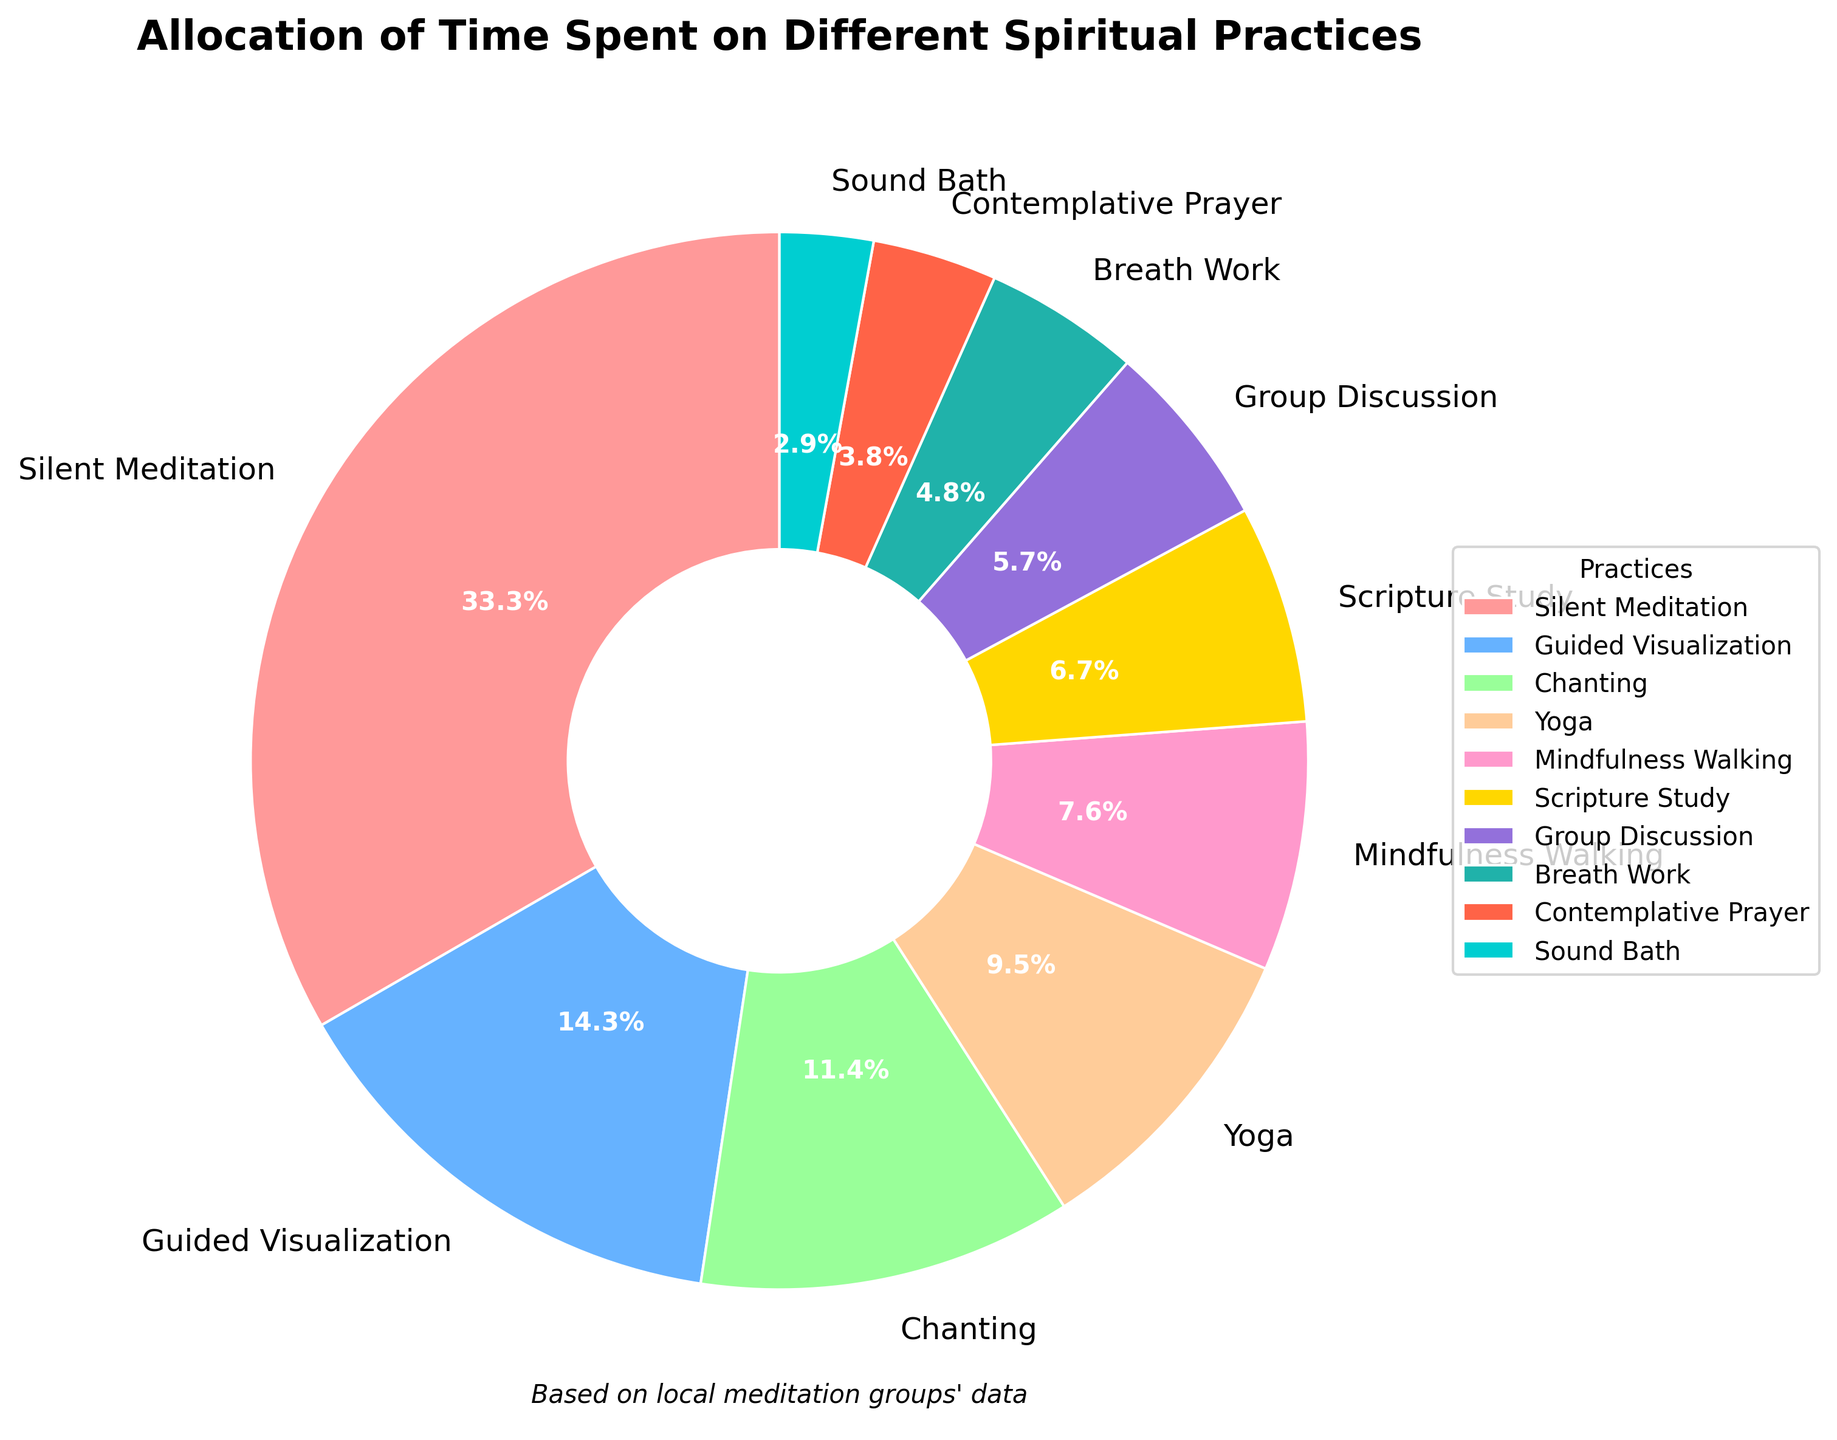What's the largest portion of the pie chart? The largest portion of the pie chart corresponds to the category with the highest percentage allocation. Silent Meditation occupies 35% of the total, which is the largest.
Answer: Silent Meditation Which spiritual practice has the smallest share? The smallest portion of the pie chart is identified by the practice with the lowest percentage allocation. Sound Bath has the smallest share at just 3%.
Answer: Sound Bath What is the combined percentage of Guided Visualization and Group Discussion? To find the combined percentage, sum the individual percentages of Guided Visualization (15%) and Group Discussion (6%). Thus, 15% + 6% = 21%.
Answer: 21% How does the time allocated to Chanting compare to Scripture Study? To compare, observe the percentages for Chanting (12%) and Scripture Study (7%) from the pie chart. Chanting is allocated a larger portion of time than Scripture Study.
Answer: Chanting has more allocation How much less percentage is spent on Contemplative Prayer compared to Silent Meditation? Subtract the percentage of Contemplative Prayer (4%) from Silent Meditation (35%) to find the difference, which is 35% - 4% = 31%.
Answer: 31% Which practices together make up more than half of the pie chart? Identify the combinations whose total percentage exceeds 50%. Silent Meditation (35%) and Guided Visualization (15%) together make up 35% + 15% = 50%, which is exactly half. To exceed 50%, add another practice. Including Chanting (12%) results in 35% + 15% + 12% = 62%.
Answer: Silent Meditation, Guided Visualization, and Chanting What is the total percentage allocated to Yoga, Mindfulness Walking, and Breath Work? Sum the individual percentages of Yoga (10%), Mindfulness Walking (8%), and Breath Work (5%). Thus, 10% + 8% + 5% = 23%.
Answer: 23% Is the percentage of time spent on Group Discussion larger or smaller than that spent on Breath Work? Compare the percentages for Group Discussion (6%) and Breath Work (5%). Since 6% is greater than 5%, Group Discussion has a larger percentage than Breath Work.
Answer: Larger Which spiritual practice uses a blue color in the pie chart? Observing the color assignments, Guided Visualization is represented in the pie chart using the blue color.
Answer: Guided Visualization 